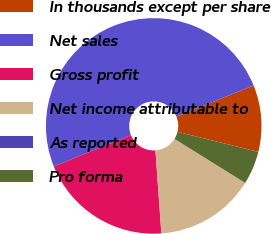Convert chart to OTSL. <chart><loc_0><loc_0><loc_500><loc_500><pie_chart><fcel>In thousands except per share<fcel>Net sales<fcel>Gross profit<fcel>Net income attributable to<fcel>As reported<fcel>Pro forma<nl><fcel>10.0%<fcel>50.0%<fcel>20.0%<fcel>15.0%<fcel>0.0%<fcel>5.0%<nl></chart> 